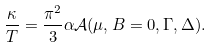<formula> <loc_0><loc_0><loc_500><loc_500>\frac { \kappa } { T } = \frac { \pi ^ { 2 } } { 3 } \alpha \mathcal { A } ( \mu , B = 0 , \Gamma , \Delta ) .</formula> 